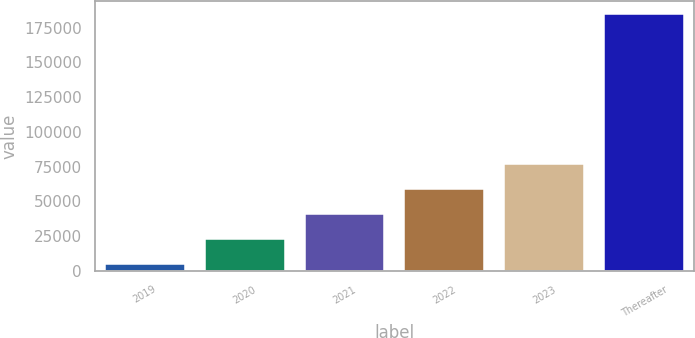Convert chart. <chart><loc_0><loc_0><loc_500><loc_500><bar_chart><fcel>2019<fcel>2020<fcel>2021<fcel>2022<fcel>2023<fcel>Thereafter<nl><fcel>4794<fcel>22794.9<fcel>40795.8<fcel>58796.7<fcel>76797.6<fcel>184803<nl></chart> 